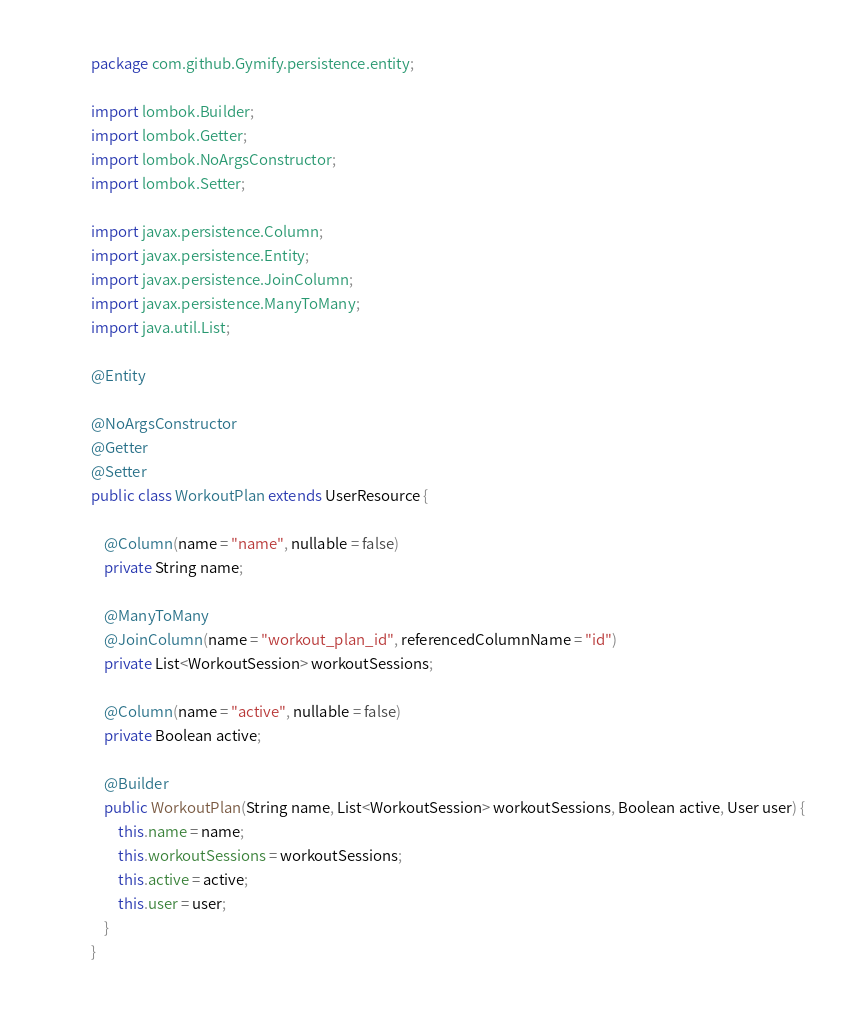<code> <loc_0><loc_0><loc_500><loc_500><_Java_>package com.github.Gymify.persistence.entity;

import lombok.Builder;
import lombok.Getter;
import lombok.NoArgsConstructor;
import lombok.Setter;

import javax.persistence.Column;
import javax.persistence.Entity;
import javax.persistence.JoinColumn;
import javax.persistence.ManyToMany;
import java.util.List;

@Entity

@NoArgsConstructor
@Getter
@Setter
public class WorkoutPlan extends UserResource {

    @Column(name = "name", nullable = false)
    private String name;

    @ManyToMany
    @JoinColumn(name = "workout_plan_id", referencedColumnName = "id")
    private List<WorkoutSession> workoutSessions;

    @Column(name = "active", nullable = false)
    private Boolean active;

    @Builder
    public WorkoutPlan(String name, List<WorkoutSession> workoutSessions, Boolean active, User user) {
        this.name = name;
        this.workoutSessions = workoutSessions;
        this.active = active;
        this.user = user;
    }
}
</code> 